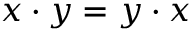Convert formula to latex. <formula><loc_0><loc_0><loc_500><loc_500>x \cdot y = y \cdot x</formula> 